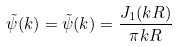Convert formula to latex. <formula><loc_0><loc_0><loc_500><loc_500>\tilde { \psi } ( { k } ) = \tilde { \psi } ( k ) = \frac { J _ { 1 } ( k R ) } { \pi k R }</formula> 